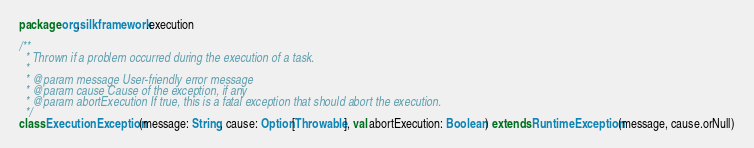<code> <loc_0><loc_0><loc_500><loc_500><_Scala_>package org.silkframework.execution

/**
  * Thrown if a problem occurred during the execution of a task.
  *
  * @param message User-friendly error message
  * @param cause Cause of the exception, if any
  * @param abortExecution If true, this is a fatal exception that should abort the execution.
  */
class ExecutionException(message: String, cause: Option[Throwable], val abortExecution: Boolean) extends RuntimeException(message, cause.orNull)
</code> 